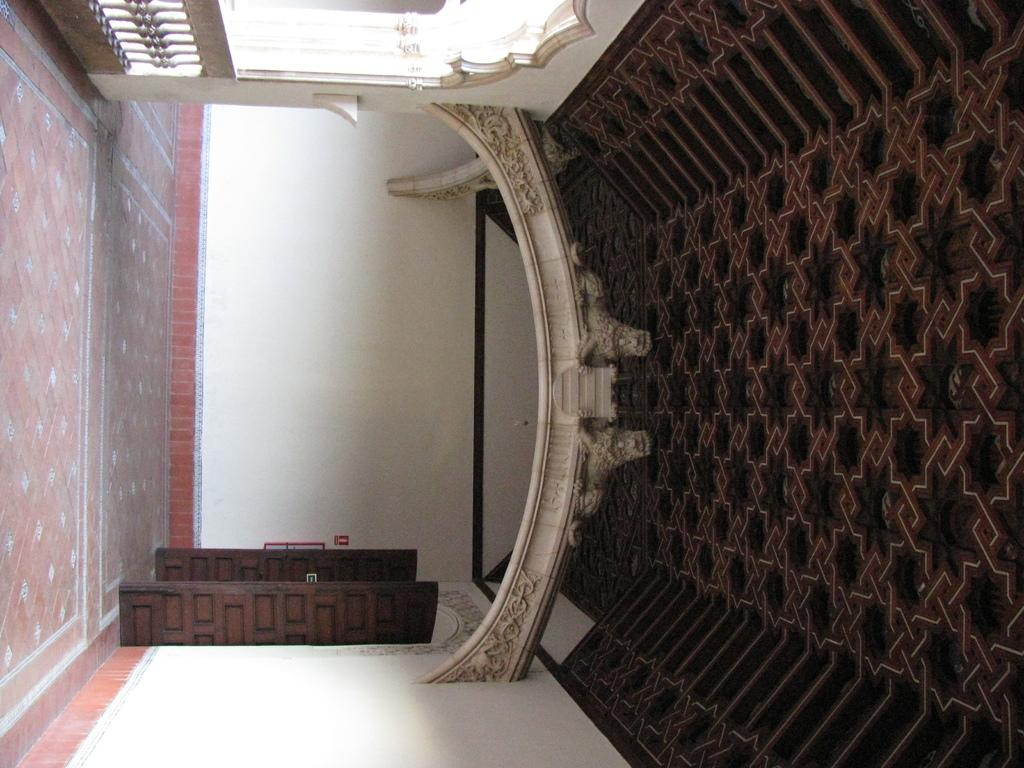How is the orientation of the image? The image appears to be rotated. What can be seen at the bottom of the image? There is a floor visible in the image. What can be seen at the top of the image? There is a ceiling visible in the image. What feature is present that allows access to another room or area? There is a door in the image. What separates the different areas or spaces in the image? There is a boundary in the image. What type of apple can be seen growing on the ceiling in the image? There is no apple or any plant growing on the ceiling in the image. How does the straw help to protect the room from the rainstorm in the image? There is no rainstorm or straw present in the image. 